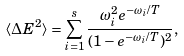<formula> <loc_0><loc_0><loc_500><loc_500>\langle \Delta E ^ { 2 } \rangle = \sum _ { i = 1 } ^ { s } \frac { \omega _ { i } ^ { 2 } e ^ { - \omega _ { i } / T } } { ( 1 - e ^ { - \omega _ { i } / T } ) ^ { 2 } } ,</formula> 